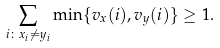<formula> <loc_0><loc_0><loc_500><loc_500>\sum _ { i \colon x _ { i } \neq y _ { i } } \min \{ v _ { x } ( i ) , v _ { y } ( i ) \} \geq 1 .</formula> 